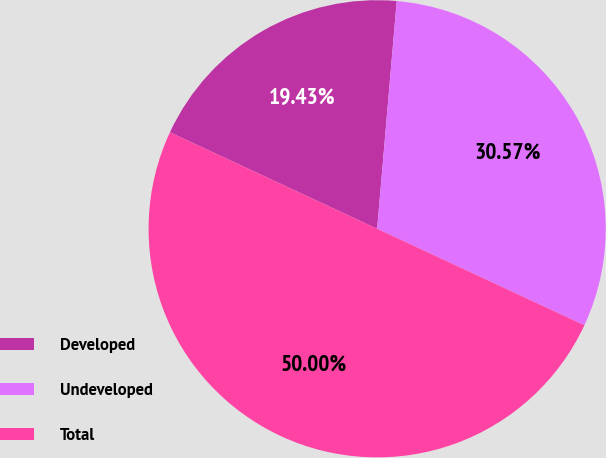<chart> <loc_0><loc_0><loc_500><loc_500><pie_chart><fcel>Developed<fcel>Undeveloped<fcel>Total<nl><fcel>19.43%<fcel>30.57%<fcel>50.0%<nl></chart> 